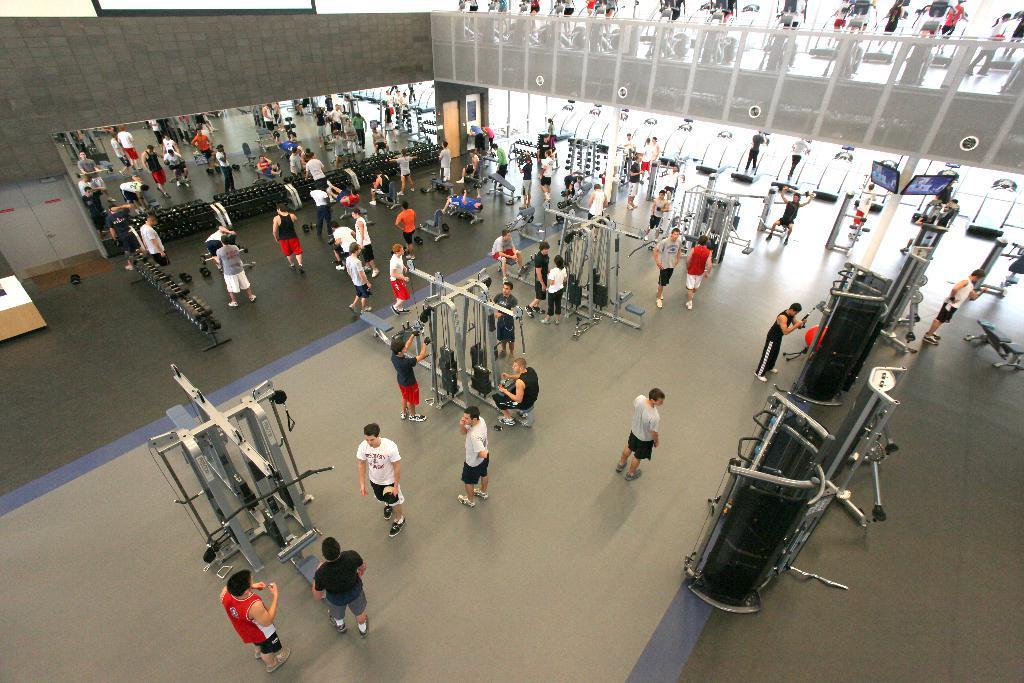Could you give a brief overview of what you see in this image? In this picture I can see it looks like a gym, a group of people are there and there is the gym equipment. 